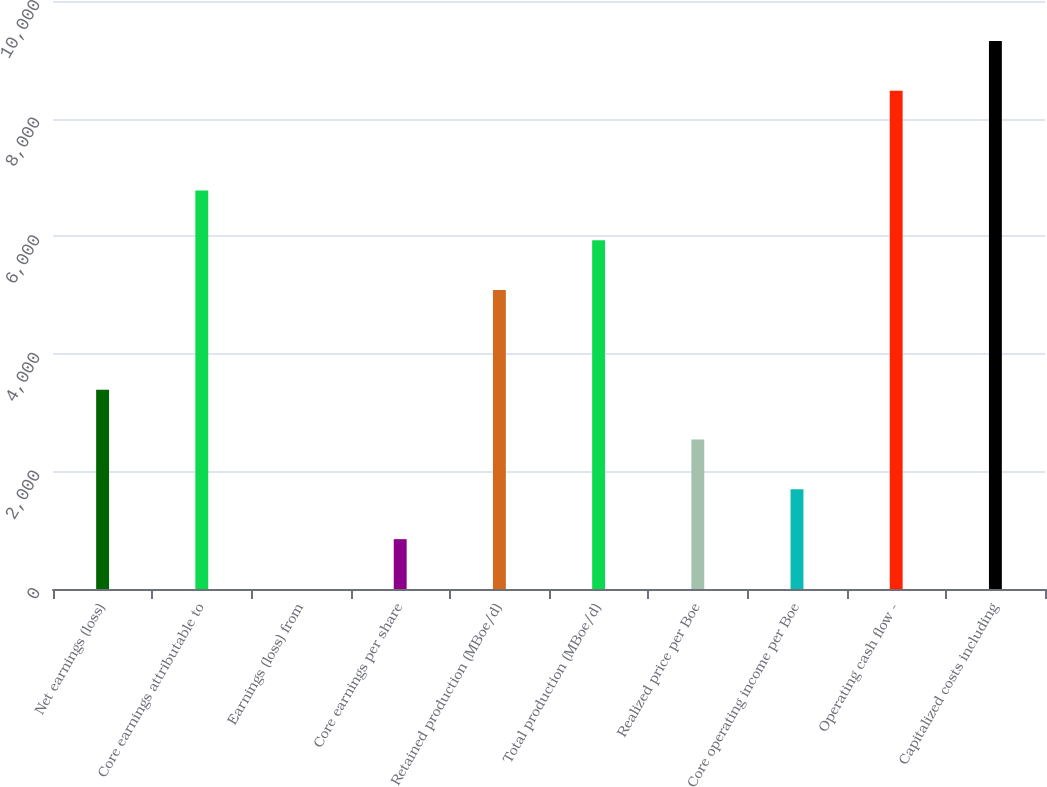Convert chart. <chart><loc_0><loc_0><loc_500><loc_500><bar_chart><fcel>Net earnings (loss)<fcel>Core earnings attributable to<fcel>Earnings (loss) from<fcel>Core earnings per share<fcel>Retained production (MBoe/d)<fcel>Total production (MBoe/d)<fcel>Realized price per Boe<fcel>Core operating income per Boe<fcel>Operating cash flow -<fcel>Capitalized costs including<nl><fcel>3389.87<fcel>6779.27<fcel>0.47<fcel>847.82<fcel>5084.57<fcel>5931.92<fcel>2542.52<fcel>1695.17<fcel>8473.97<fcel>9321.32<nl></chart> 